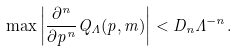<formula> <loc_0><loc_0><loc_500><loc_500>\max \left | \frac { \partial ^ { n } } { \partial p ^ { n } } Q _ { \Lambda } ( p , m ) \right | < D _ { n } \Lambda ^ { - n } .</formula> 